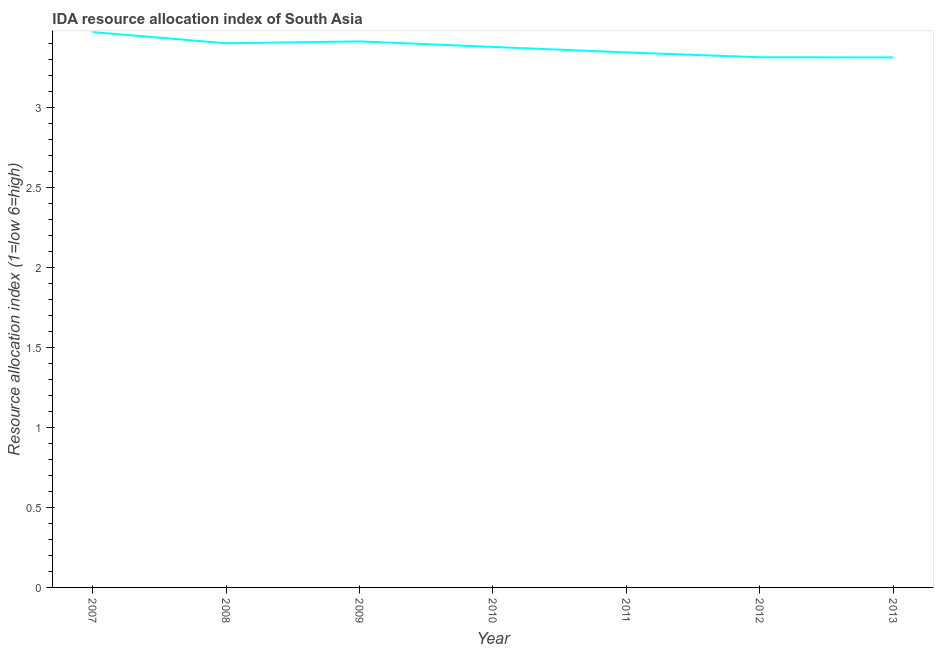What is the ida resource allocation index in 2011?
Keep it short and to the point. 3.34. Across all years, what is the maximum ida resource allocation index?
Give a very brief answer. 3.47. Across all years, what is the minimum ida resource allocation index?
Make the answer very short. 3.31. What is the sum of the ida resource allocation index?
Your answer should be compact. 23.62. What is the difference between the ida resource allocation index in 2007 and 2009?
Give a very brief answer. 0.06. What is the average ida resource allocation index per year?
Your answer should be compact. 3.37. What is the median ida resource allocation index?
Provide a succinct answer. 3.38. What is the ratio of the ida resource allocation index in 2009 to that in 2012?
Give a very brief answer. 1.03. Is the ida resource allocation index in 2010 less than that in 2013?
Make the answer very short. No. Is the difference between the ida resource allocation index in 2009 and 2011 greater than the difference between any two years?
Keep it short and to the point. No. What is the difference between the highest and the second highest ida resource allocation index?
Your answer should be very brief. 0.06. Is the sum of the ida resource allocation index in 2010 and 2011 greater than the maximum ida resource allocation index across all years?
Offer a very short reply. Yes. What is the difference between the highest and the lowest ida resource allocation index?
Give a very brief answer. 0.16. In how many years, is the ida resource allocation index greater than the average ida resource allocation index taken over all years?
Offer a very short reply. 4. What is the difference between two consecutive major ticks on the Y-axis?
Your answer should be very brief. 0.5. Are the values on the major ticks of Y-axis written in scientific E-notation?
Make the answer very short. No. Does the graph contain any zero values?
Keep it short and to the point. No. Does the graph contain grids?
Give a very brief answer. No. What is the title of the graph?
Your answer should be compact. IDA resource allocation index of South Asia. What is the label or title of the Y-axis?
Keep it short and to the point. Resource allocation index (1=low 6=high). What is the Resource allocation index (1=low 6=high) in 2007?
Your response must be concise. 3.47. What is the Resource allocation index (1=low 6=high) of 2009?
Ensure brevity in your answer.  3.41. What is the Resource allocation index (1=low 6=high) of 2010?
Give a very brief answer. 3.38. What is the Resource allocation index (1=low 6=high) in 2011?
Your answer should be compact. 3.34. What is the Resource allocation index (1=low 6=high) in 2012?
Your response must be concise. 3.31. What is the Resource allocation index (1=low 6=high) of 2013?
Offer a terse response. 3.31. What is the difference between the Resource allocation index (1=low 6=high) in 2007 and 2008?
Your answer should be very brief. 0.07. What is the difference between the Resource allocation index (1=low 6=high) in 2007 and 2009?
Provide a succinct answer. 0.06. What is the difference between the Resource allocation index (1=low 6=high) in 2007 and 2010?
Offer a terse response. 0.09. What is the difference between the Resource allocation index (1=low 6=high) in 2007 and 2011?
Offer a very short reply. 0.13. What is the difference between the Resource allocation index (1=low 6=high) in 2007 and 2012?
Give a very brief answer. 0.16. What is the difference between the Resource allocation index (1=low 6=high) in 2007 and 2013?
Your answer should be compact. 0.16. What is the difference between the Resource allocation index (1=low 6=high) in 2008 and 2009?
Offer a terse response. -0.01. What is the difference between the Resource allocation index (1=low 6=high) in 2008 and 2010?
Your answer should be compact. 0.02. What is the difference between the Resource allocation index (1=low 6=high) in 2008 and 2011?
Provide a short and direct response. 0.06. What is the difference between the Resource allocation index (1=low 6=high) in 2008 and 2012?
Give a very brief answer. 0.09. What is the difference between the Resource allocation index (1=low 6=high) in 2008 and 2013?
Provide a short and direct response. 0.09. What is the difference between the Resource allocation index (1=low 6=high) in 2009 and 2010?
Your response must be concise. 0.03. What is the difference between the Resource allocation index (1=low 6=high) in 2009 and 2011?
Offer a very short reply. 0.07. What is the difference between the Resource allocation index (1=low 6=high) in 2009 and 2012?
Your answer should be compact. 0.1. What is the difference between the Resource allocation index (1=low 6=high) in 2010 and 2011?
Give a very brief answer. 0.03. What is the difference between the Resource allocation index (1=low 6=high) in 2010 and 2012?
Your answer should be very brief. 0.06. What is the difference between the Resource allocation index (1=low 6=high) in 2010 and 2013?
Ensure brevity in your answer.  0.07. What is the difference between the Resource allocation index (1=low 6=high) in 2011 and 2012?
Your answer should be compact. 0.03. What is the difference between the Resource allocation index (1=low 6=high) in 2011 and 2013?
Offer a terse response. 0.03. What is the difference between the Resource allocation index (1=low 6=high) in 2012 and 2013?
Provide a short and direct response. 0. What is the ratio of the Resource allocation index (1=low 6=high) in 2007 to that in 2008?
Provide a short and direct response. 1.02. What is the ratio of the Resource allocation index (1=low 6=high) in 2007 to that in 2009?
Your answer should be compact. 1.02. What is the ratio of the Resource allocation index (1=low 6=high) in 2007 to that in 2011?
Offer a very short reply. 1.04. What is the ratio of the Resource allocation index (1=low 6=high) in 2007 to that in 2012?
Give a very brief answer. 1.05. What is the ratio of the Resource allocation index (1=low 6=high) in 2007 to that in 2013?
Your answer should be compact. 1.05. What is the ratio of the Resource allocation index (1=low 6=high) in 2008 to that in 2011?
Keep it short and to the point. 1.02. What is the ratio of the Resource allocation index (1=low 6=high) in 2008 to that in 2013?
Offer a very short reply. 1.03. What is the ratio of the Resource allocation index (1=low 6=high) in 2009 to that in 2010?
Provide a short and direct response. 1.01. What is the ratio of the Resource allocation index (1=low 6=high) in 2009 to that in 2011?
Keep it short and to the point. 1.02. What is the ratio of the Resource allocation index (1=low 6=high) in 2010 to that in 2011?
Give a very brief answer. 1.01. What is the ratio of the Resource allocation index (1=low 6=high) in 2010 to that in 2012?
Ensure brevity in your answer.  1.02. What is the ratio of the Resource allocation index (1=low 6=high) in 2012 to that in 2013?
Give a very brief answer. 1. 